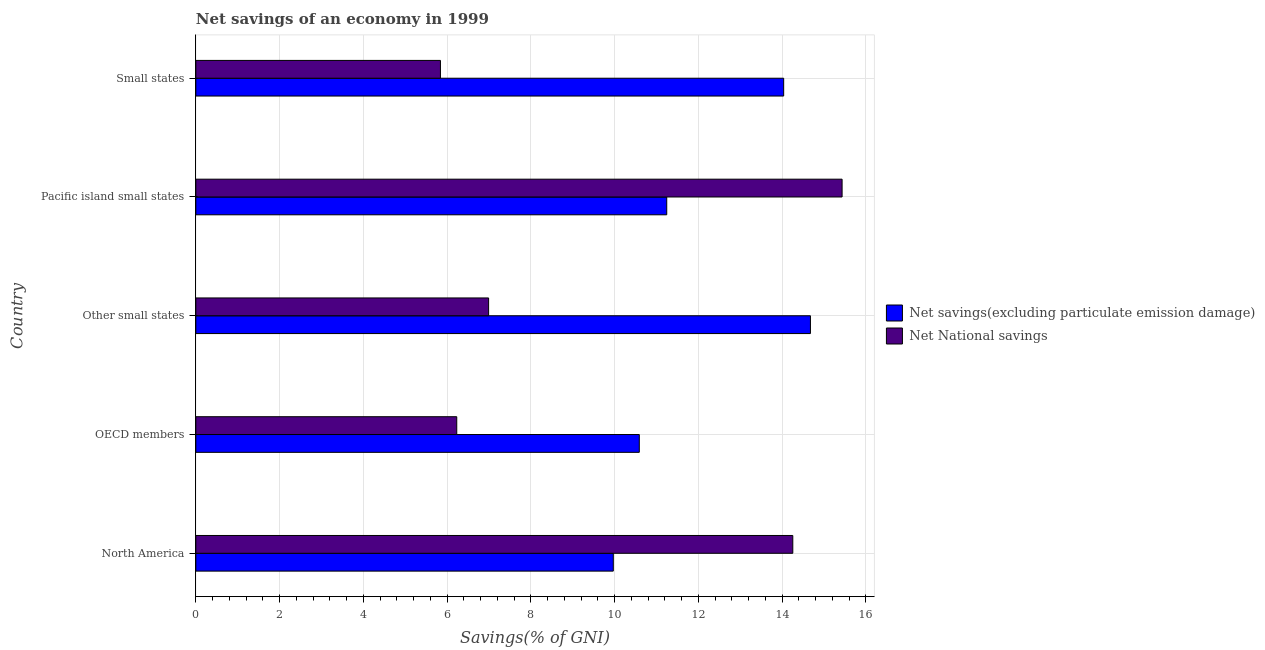How many different coloured bars are there?
Offer a very short reply. 2. How many groups of bars are there?
Your response must be concise. 5. Are the number of bars per tick equal to the number of legend labels?
Ensure brevity in your answer.  Yes. Are the number of bars on each tick of the Y-axis equal?
Offer a very short reply. Yes. What is the label of the 5th group of bars from the top?
Give a very brief answer. North America. In how many cases, is the number of bars for a given country not equal to the number of legend labels?
Give a very brief answer. 0. What is the net savings(excluding particulate emission damage) in Other small states?
Provide a succinct answer. 14.67. Across all countries, what is the maximum net national savings?
Your response must be concise. 15.43. Across all countries, what is the minimum net national savings?
Your answer should be very brief. 5.84. In which country was the net savings(excluding particulate emission damage) maximum?
Keep it short and to the point. Other small states. In which country was the net national savings minimum?
Provide a short and direct response. Small states. What is the total net savings(excluding particulate emission damage) in the graph?
Give a very brief answer. 60.51. What is the difference between the net national savings in Other small states and that in Pacific island small states?
Your answer should be compact. -8.44. What is the difference between the net savings(excluding particulate emission damage) in Small states and the net national savings in Other small states?
Offer a terse response. 7.04. What is the average net savings(excluding particulate emission damage) per country?
Provide a succinct answer. 12.1. What is the difference between the net national savings and net savings(excluding particulate emission damage) in Small states?
Give a very brief answer. -8.2. What is the ratio of the net savings(excluding particulate emission damage) in OECD members to that in Small states?
Provide a short and direct response. 0.75. What is the difference between the highest and the second highest net national savings?
Provide a succinct answer. 1.18. What is the difference between the highest and the lowest net savings(excluding particulate emission damage)?
Provide a short and direct response. 4.71. Is the sum of the net national savings in North America and Small states greater than the maximum net savings(excluding particulate emission damage) across all countries?
Offer a terse response. Yes. What does the 1st bar from the top in North America represents?
Give a very brief answer. Net National savings. What does the 2nd bar from the bottom in Small states represents?
Provide a short and direct response. Net National savings. Are all the bars in the graph horizontal?
Your answer should be compact. Yes. How many countries are there in the graph?
Your answer should be very brief. 5. What is the difference between two consecutive major ticks on the X-axis?
Keep it short and to the point. 2. Does the graph contain any zero values?
Make the answer very short. No. Does the graph contain grids?
Make the answer very short. Yes. How are the legend labels stacked?
Your answer should be compact. Vertical. What is the title of the graph?
Your response must be concise. Net savings of an economy in 1999. What is the label or title of the X-axis?
Make the answer very short. Savings(% of GNI). What is the label or title of the Y-axis?
Offer a very short reply. Country. What is the Savings(% of GNI) of Net savings(excluding particulate emission damage) in North America?
Ensure brevity in your answer.  9.97. What is the Savings(% of GNI) in Net National savings in North America?
Keep it short and to the point. 14.25. What is the Savings(% of GNI) in Net savings(excluding particulate emission damage) in OECD members?
Offer a very short reply. 10.59. What is the Savings(% of GNI) in Net National savings in OECD members?
Offer a terse response. 6.23. What is the Savings(% of GNI) of Net savings(excluding particulate emission damage) in Other small states?
Ensure brevity in your answer.  14.67. What is the Savings(% of GNI) in Net National savings in Other small states?
Your response must be concise. 6.99. What is the Savings(% of GNI) in Net savings(excluding particulate emission damage) in Pacific island small states?
Provide a short and direct response. 11.24. What is the Savings(% of GNI) of Net National savings in Pacific island small states?
Make the answer very short. 15.43. What is the Savings(% of GNI) in Net savings(excluding particulate emission damage) in Small states?
Provide a short and direct response. 14.04. What is the Savings(% of GNI) in Net National savings in Small states?
Provide a succinct answer. 5.84. Across all countries, what is the maximum Savings(% of GNI) of Net savings(excluding particulate emission damage)?
Keep it short and to the point. 14.67. Across all countries, what is the maximum Savings(% of GNI) in Net National savings?
Your answer should be very brief. 15.43. Across all countries, what is the minimum Savings(% of GNI) in Net savings(excluding particulate emission damage)?
Ensure brevity in your answer.  9.97. Across all countries, what is the minimum Savings(% of GNI) of Net National savings?
Your response must be concise. 5.84. What is the total Savings(% of GNI) in Net savings(excluding particulate emission damage) in the graph?
Give a very brief answer. 60.51. What is the total Savings(% of GNI) in Net National savings in the graph?
Offer a very short reply. 48.74. What is the difference between the Savings(% of GNI) of Net savings(excluding particulate emission damage) in North America and that in OECD members?
Give a very brief answer. -0.62. What is the difference between the Savings(% of GNI) in Net National savings in North America and that in OECD members?
Your answer should be very brief. 8.02. What is the difference between the Savings(% of GNI) of Net savings(excluding particulate emission damage) in North America and that in Other small states?
Give a very brief answer. -4.71. What is the difference between the Savings(% of GNI) of Net National savings in North America and that in Other small states?
Offer a very short reply. 7.26. What is the difference between the Savings(% of GNI) in Net savings(excluding particulate emission damage) in North America and that in Pacific island small states?
Make the answer very short. -1.28. What is the difference between the Savings(% of GNI) of Net National savings in North America and that in Pacific island small states?
Provide a succinct answer. -1.18. What is the difference between the Savings(% of GNI) of Net savings(excluding particulate emission damage) in North America and that in Small states?
Provide a short and direct response. -4.07. What is the difference between the Savings(% of GNI) of Net National savings in North America and that in Small states?
Offer a very short reply. 8.41. What is the difference between the Savings(% of GNI) of Net savings(excluding particulate emission damage) in OECD members and that in Other small states?
Ensure brevity in your answer.  -4.09. What is the difference between the Savings(% of GNI) of Net National savings in OECD members and that in Other small states?
Provide a short and direct response. -0.76. What is the difference between the Savings(% of GNI) in Net savings(excluding particulate emission damage) in OECD members and that in Pacific island small states?
Your response must be concise. -0.66. What is the difference between the Savings(% of GNI) in Net National savings in OECD members and that in Pacific island small states?
Your response must be concise. -9.2. What is the difference between the Savings(% of GNI) in Net savings(excluding particulate emission damage) in OECD members and that in Small states?
Your answer should be very brief. -3.45. What is the difference between the Savings(% of GNI) in Net National savings in OECD members and that in Small states?
Ensure brevity in your answer.  0.39. What is the difference between the Savings(% of GNI) of Net savings(excluding particulate emission damage) in Other small states and that in Pacific island small states?
Ensure brevity in your answer.  3.43. What is the difference between the Savings(% of GNI) of Net National savings in Other small states and that in Pacific island small states?
Keep it short and to the point. -8.44. What is the difference between the Savings(% of GNI) of Net savings(excluding particulate emission damage) in Other small states and that in Small states?
Your answer should be very brief. 0.64. What is the difference between the Savings(% of GNI) in Net National savings in Other small states and that in Small states?
Your answer should be compact. 1.15. What is the difference between the Savings(% of GNI) in Net savings(excluding particulate emission damage) in Pacific island small states and that in Small states?
Give a very brief answer. -2.79. What is the difference between the Savings(% of GNI) in Net National savings in Pacific island small states and that in Small states?
Keep it short and to the point. 9.59. What is the difference between the Savings(% of GNI) in Net savings(excluding particulate emission damage) in North America and the Savings(% of GNI) in Net National savings in OECD members?
Your response must be concise. 3.74. What is the difference between the Savings(% of GNI) in Net savings(excluding particulate emission damage) in North America and the Savings(% of GNI) in Net National savings in Other small states?
Keep it short and to the point. 2.98. What is the difference between the Savings(% of GNI) in Net savings(excluding particulate emission damage) in North America and the Savings(% of GNI) in Net National savings in Pacific island small states?
Offer a very short reply. -5.46. What is the difference between the Savings(% of GNI) in Net savings(excluding particulate emission damage) in North America and the Savings(% of GNI) in Net National savings in Small states?
Ensure brevity in your answer.  4.13. What is the difference between the Savings(% of GNI) of Net savings(excluding particulate emission damage) in OECD members and the Savings(% of GNI) of Net National savings in Other small states?
Your answer should be very brief. 3.6. What is the difference between the Savings(% of GNI) of Net savings(excluding particulate emission damage) in OECD members and the Savings(% of GNI) of Net National savings in Pacific island small states?
Provide a succinct answer. -4.84. What is the difference between the Savings(% of GNI) of Net savings(excluding particulate emission damage) in OECD members and the Savings(% of GNI) of Net National savings in Small states?
Make the answer very short. 4.75. What is the difference between the Savings(% of GNI) of Net savings(excluding particulate emission damage) in Other small states and the Savings(% of GNI) of Net National savings in Pacific island small states?
Offer a very short reply. -0.76. What is the difference between the Savings(% of GNI) of Net savings(excluding particulate emission damage) in Other small states and the Savings(% of GNI) of Net National savings in Small states?
Your answer should be very brief. 8.83. What is the difference between the Savings(% of GNI) of Net savings(excluding particulate emission damage) in Pacific island small states and the Savings(% of GNI) of Net National savings in Small states?
Make the answer very short. 5.4. What is the average Savings(% of GNI) in Net savings(excluding particulate emission damage) per country?
Offer a terse response. 12.1. What is the average Savings(% of GNI) of Net National savings per country?
Your response must be concise. 9.75. What is the difference between the Savings(% of GNI) of Net savings(excluding particulate emission damage) and Savings(% of GNI) of Net National savings in North America?
Make the answer very short. -4.29. What is the difference between the Savings(% of GNI) of Net savings(excluding particulate emission damage) and Savings(% of GNI) of Net National savings in OECD members?
Offer a terse response. 4.36. What is the difference between the Savings(% of GNI) in Net savings(excluding particulate emission damage) and Savings(% of GNI) in Net National savings in Other small states?
Your response must be concise. 7.68. What is the difference between the Savings(% of GNI) of Net savings(excluding particulate emission damage) and Savings(% of GNI) of Net National savings in Pacific island small states?
Make the answer very short. -4.19. What is the difference between the Savings(% of GNI) in Net savings(excluding particulate emission damage) and Savings(% of GNI) in Net National savings in Small states?
Your answer should be compact. 8.2. What is the ratio of the Savings(% of GNI) in Net savings(excluding particulate emission damage) in North America to that in OECD members?
Your response must be concise. 0.94. What is the ratio of the Savings(% of GNI) in Net National savings in North America to that in OECD members?
Provide a short and direct response. 2.29. What is the ratio of the Savings(% of GNI) in Net savings(excluding particulate emission damage) in North America to that in Other small states?
Make the answer very short. 0.68. What is the ratio of the Savings(% of GNI) in Net National savings in North America to that in Other small states?
Offer a terse response. 2.04. What is the ratio of the Savings(% of GNI) in Net savings(excluding particulate emission damage) in North America to that in Pacific island small states?
Offer a terse response. 0.89. What is the ratio of the Savings(% of GNI) of Net National savings in North America to that in Pacific island small states?
Your answer should be compact. 0.92. What is the ratio of the Savings(% of GNI) in Net savings(excluding particulate emission damage) in North America to that in Small states?
Offer a very short reply. 0.71. What is the ratio of the Savings(% of GNI) in Net National savings in North America to that in Small states?
Your answer should be very brief. 2.44. What is the ratio of the Savings(% of GNI) of Net savings(excluding particulate emission damage) in OECD members to that in Other small states?
Ensure brevity in your answer.  0.72. What is the ratio of the Savings(% of GNI) in Net National savings in OECD members to that in Other small states?
Your response must be concise. 0.89. What is the ratio of the Savings(% of GNI) of Net savings(excluding particulate emission damage) in OECD members to that in Pacific island small states?
Your answer should be very brief. 0.94. What is the ratio of the Savings(% of GNI) in Net National savings in OECD members to that in Pacific island small states?
Give a very brief answer. 0.4. What is the ratio of the Savings(% of GNI) in Net savings(excluding particulate emission damage) in OECD members to that in Small states?
Make the answer very short. 0.75. What is the ratio of the Savings(% of GNI) of Net National savings in OECD members to that in Small states?
Offer a terse response. 1.07. What is the ratio of the Savings(% of GNI) in Net savings(excluding particulate emission damage) in Other small states to that in Pacific island small states?
Your response must be concise. 1.31. What is the ratio of the Savings(% of GNI) in Net National savings in Other small states to that in Pacific island small states?
Your answer should be compact. 0.45. What is the ratio of the Savings(% of GNI) of Net savings(excluding particulate emission damage) in Other small states to that in Small states?
Keep it short and to the point. 1.05. What is the ratio of the Savings(% of GNI) in Net National savings in Other small states to that in Small states?
Offer a terse response. 1.2. What is the ratio of the Savings(% of GNI) in Net savings(excluding particulate emission damage) in Pacific island small states to that in Small states?
Give a very brief answer. 0.8. What is the ratio of the Savings(% of GNI) in Net National savings in Pacific island small states to that in Small states?
Offer a terse response. 2.64. What is the difference between the highest and the second highest Savings(% of GNI) in Net savings(excluding particulate emission damage)?
Provide a succinct answer. 0.64. What is the difference between the highest and the second highest Savings(% of GNI) of Net National savings?
Keep it short and to the point. 1.18. What is the difference between the highest and the lowest Savings(% of GNI) in Net savings(excluding particulate emission damage)?
Your response must be concise. 4.71. What is the difference between the highest and the lowest Savings(% of GNI) of Net National savings?
Ensure brevity in your answer.  9.59. 